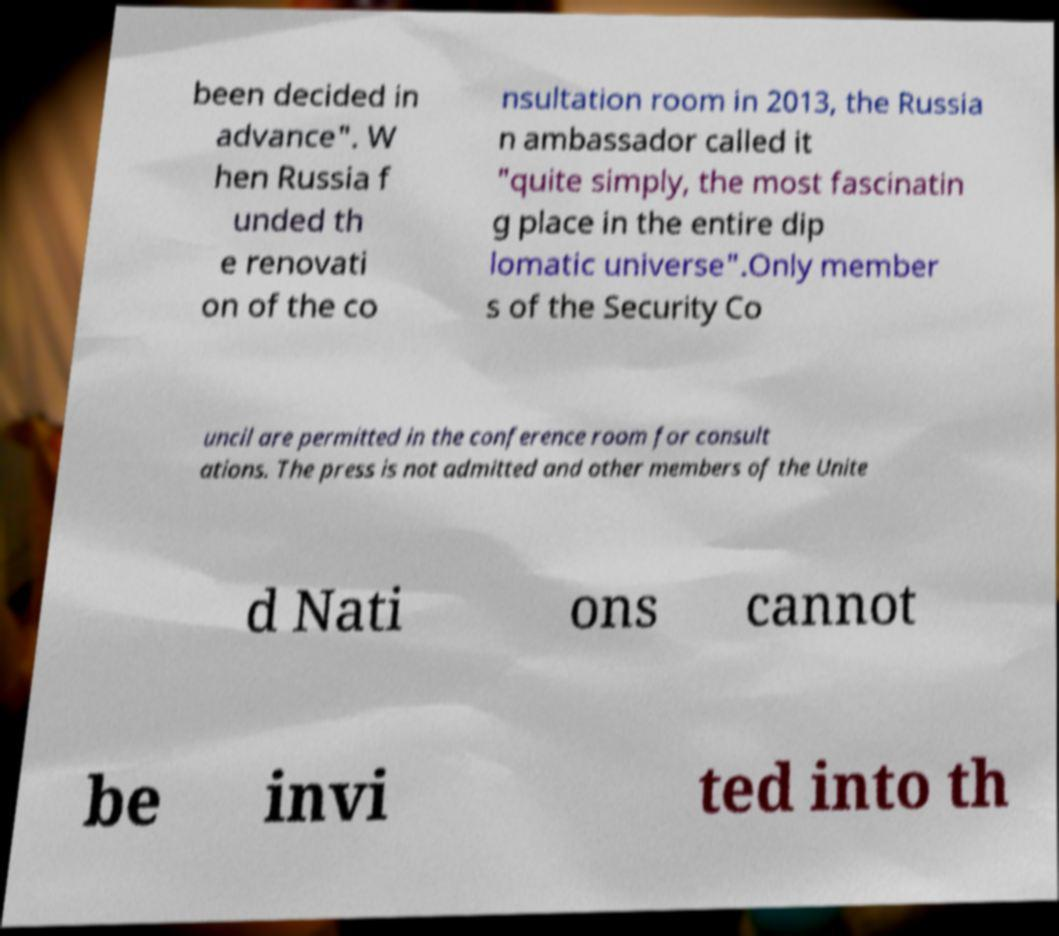I need the written content from this picture converted into text. Can you do that? been decided in advance". W hen Russia f unded th e renovati on of the co nsultation room in 2013, the Russia n ambassador called it "quite simply, the most fascinatin g place in the entire dip lomatic universe".Only member s of the Security Co uncil are permitted in the conference room for consult ations. The press is not admitted and other members of the Unite d Nati ons cannot be invi ted into th 